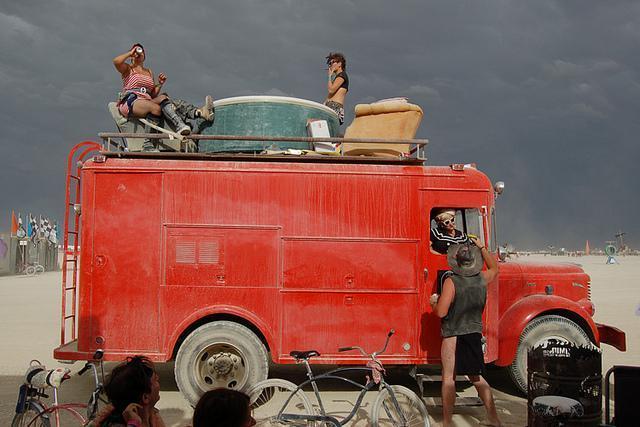How many people are in this picture?
Give a very brief answer. 6. How many bicycles are in the picture?
Give a very brief answer. 2. How many people are there?
Give a very brief answer. 4. 